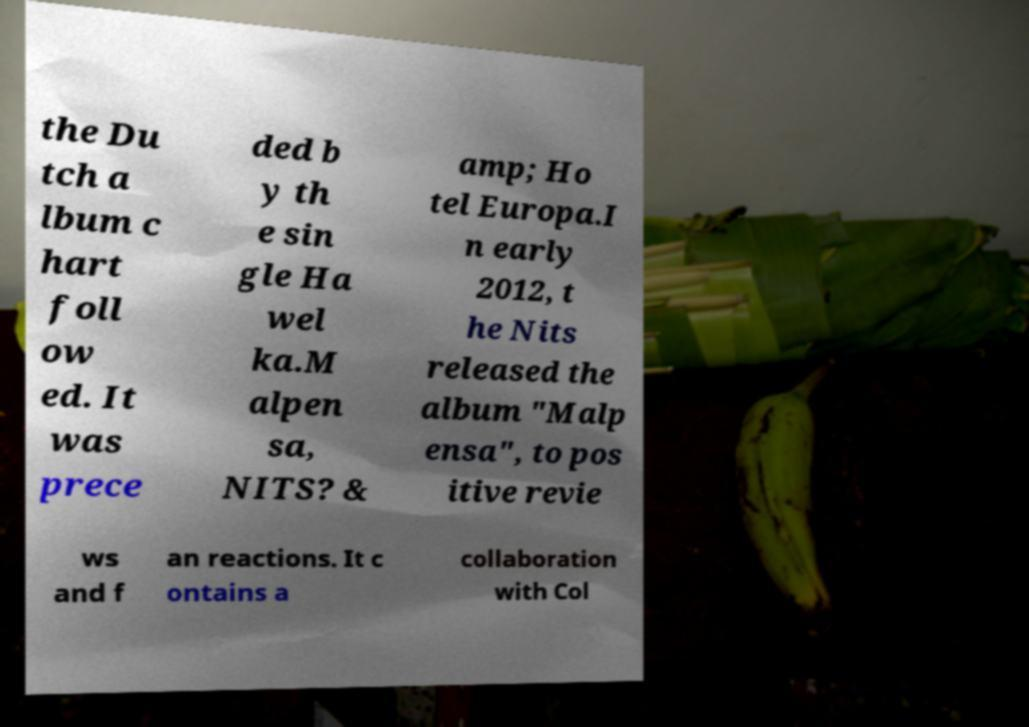Can you accurately transcribe the text from the provided image for me? the Du tch a lbum c hart foll ow ed. It was prece ded b y th e sin gle Ha wel ka.M alpen sa, NITS? & amp; Ho tel Europa.I n early 2012, t he Nits released the album "Malp ensa", to pos itive revie ws and f an reactions. It c ontains a collaboration with Col 